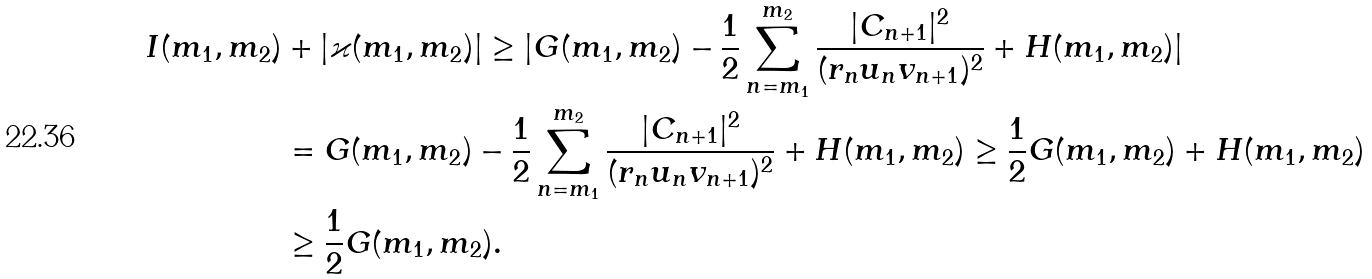<formula> <loc_0><loc_0><loc_500><loc_500>I ( m _ { 1 } , m _ { 2 } ) & + | \varkappa ( m _ { 1 } , m _ { 2 } ) | \geq | G ( m _ { 1 } , m _ { 2 } ) - \frac { 1 } { 2 } \sum _ { n = m _ { 1 } } ^ { m _ { 2 } } \frac { | C _ { n + 1 } | ^ { 2 } } { ( r _ { n } u _ { n } v _ { n + 1 } ) ^ { 2 } } + H ( m _ { 1 } , m _ { 2 } ) | \\ & = G ( m _ { 1 } , m _ { 2 } ) - \frac { 1 } { 2 } \sum _ { n = m _ { 1 } } ^ { m _ { 2 } } \frac { | C _ { n + 1 } | ^ { 2 } } { ( r _ { n } u _ { n } v _ { n + 1 } ) ^ { 2 } } + H ( m _ { 1 } , m _ { 2 } ) \geq \frac { 1 } { 2 } G ( m _ { 1 } , m _ { 2 } ) + H ( m _ { 1 } , m _ { 2 } ) \\ & \geq \frac { 1 } { 2 } G ( m _ { 1 } , m _ { 2 } ) .</formula> 